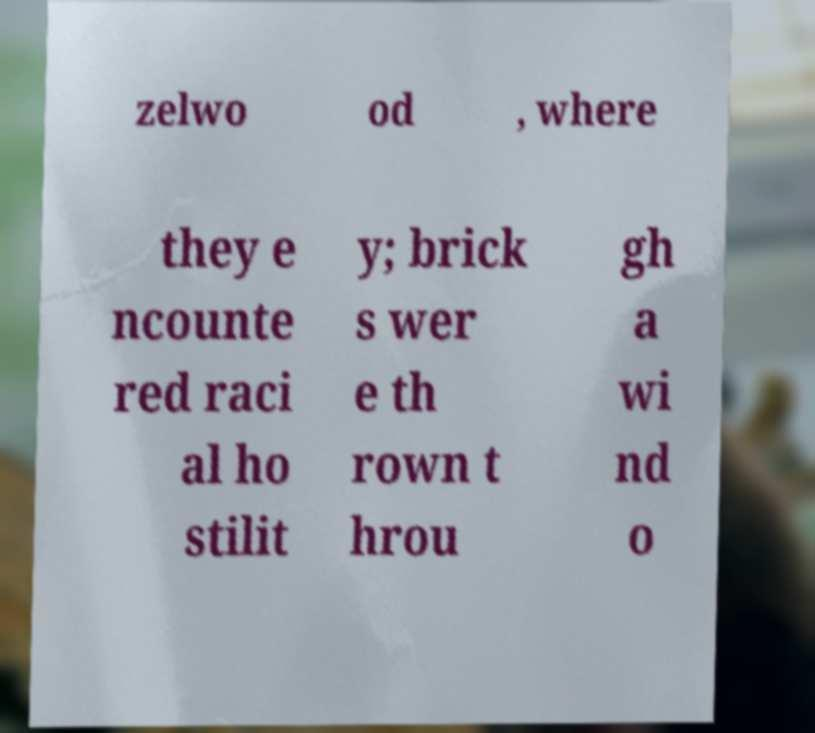I need the written content from this picture converted into text. Can you do that? zelwo od , where they e ncounte red raci al ho stilit y; brick s wer e th rown t hrou gh a wi nd o 